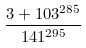<formula> <loc_0><loc_0><loc_500><loc_500>\frac { 3 + 1 0 3 ^ { 2 8 5 } } { 1 4 1 ^ { 2 9 5 } }</formula> 